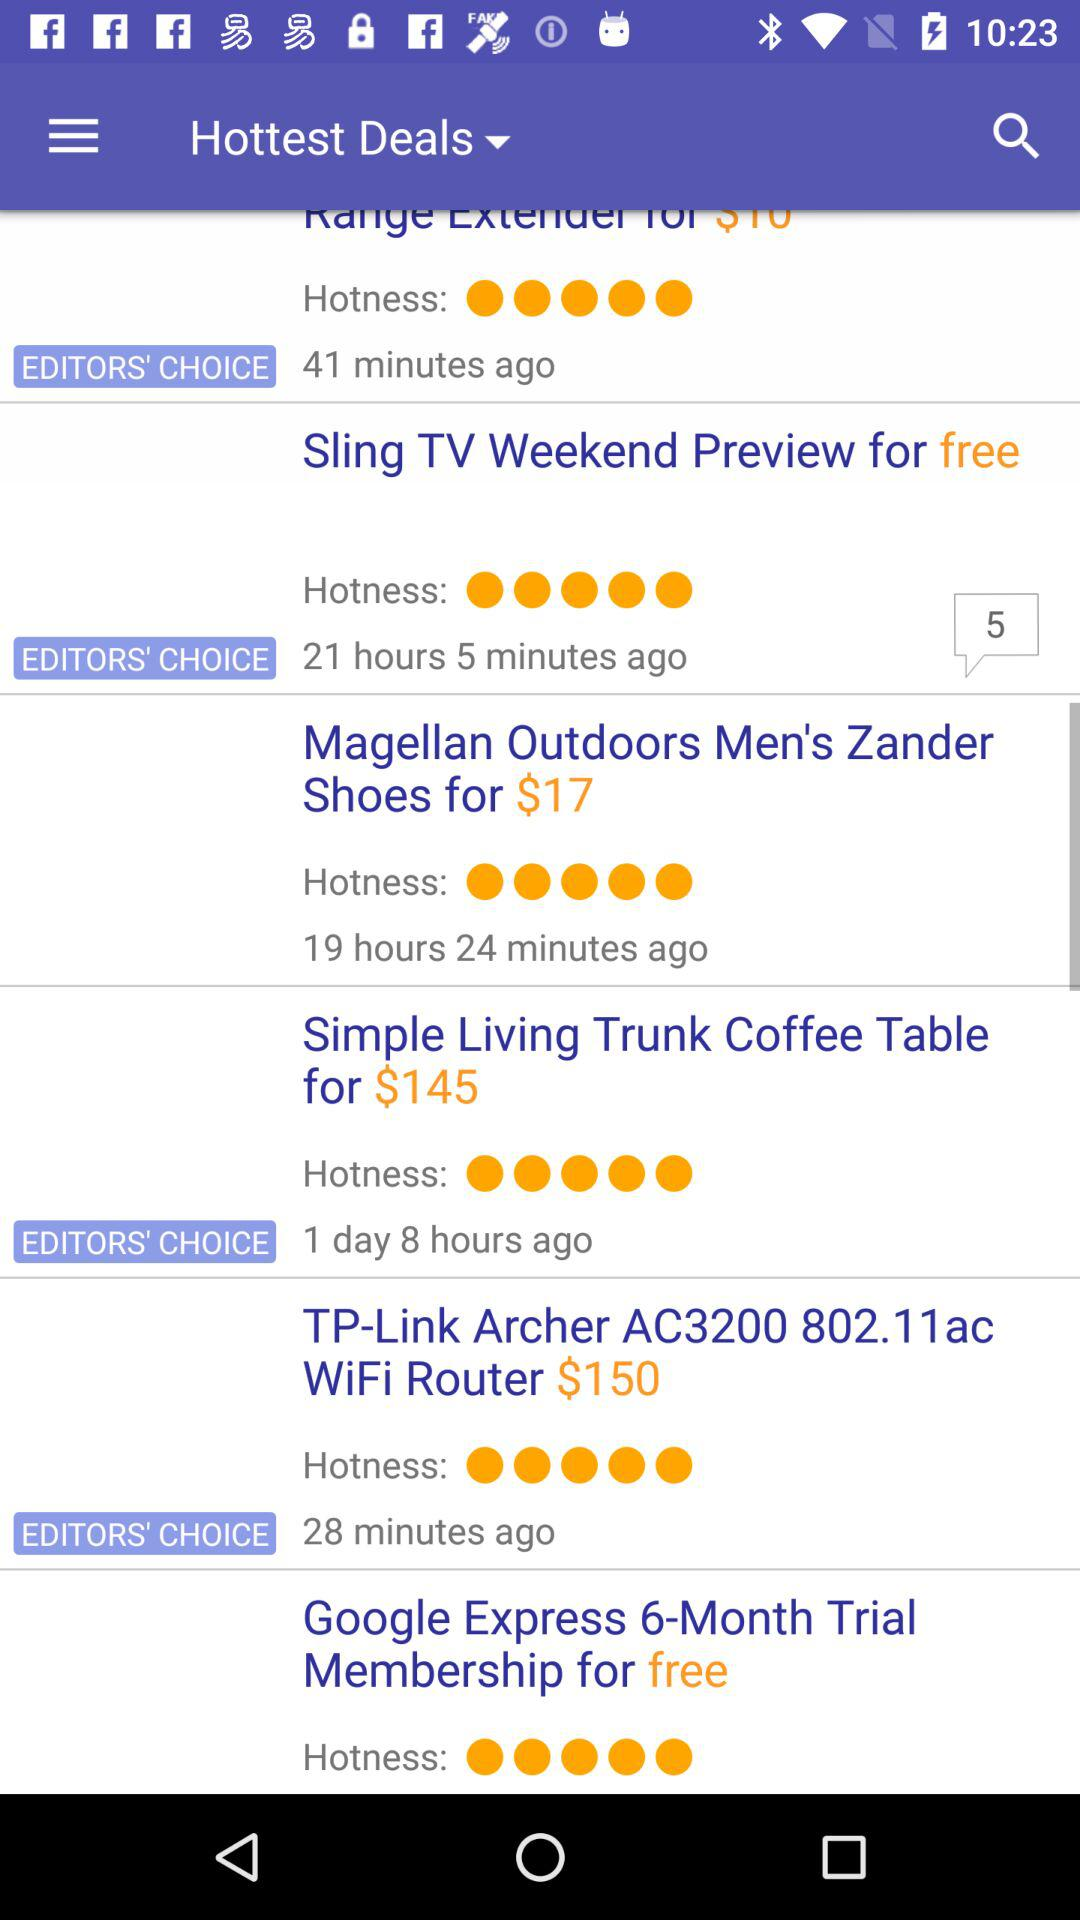How many items are Editors' Choice?
Answer the question using a single word or phrase. 4 